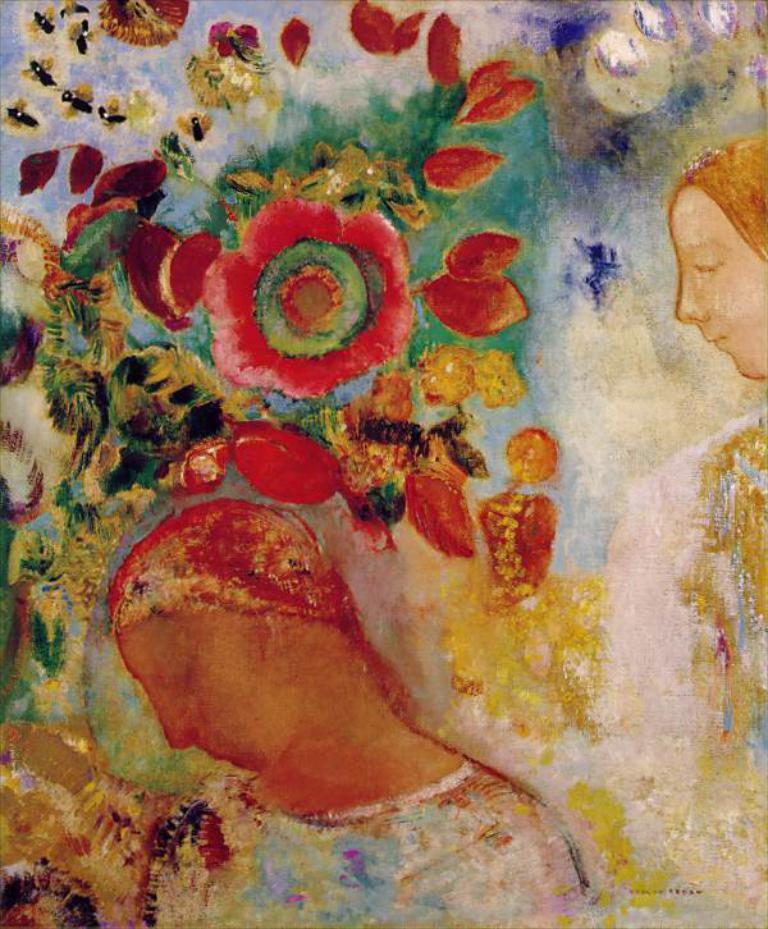What is the main subject of the image? The image contains a painting. What is depicted in the painting? The painting depicts persons and includes flowers and leaves. What type of game are the persons playing in the painting? There is no indication of a game being played in the painting; it features persons, flowers, and leaves. 